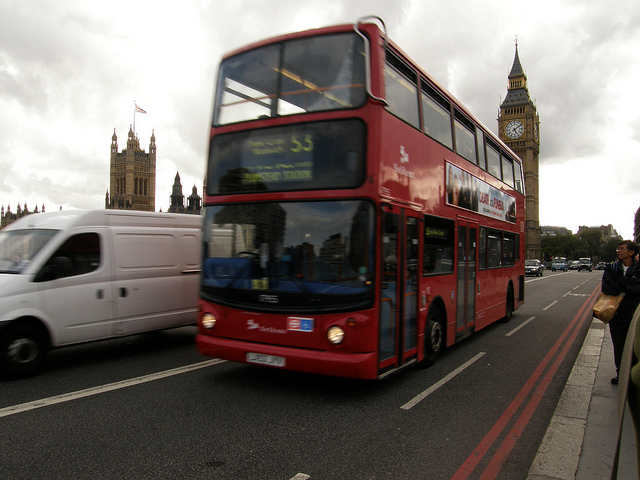<image>Which bus is the smallest? It is ambiguous which bus is the smallest. What two English words sound like the pronunciation of the black letters on the bus? There are no black letters on the bus. So, it is unknown what two English words sound like the pronunciation of non-existent black letters. What country do the flags represent? I am not sure the country of the flags. It can be seen Portugal, UK, France or others. Which bus is the smallest? I don't know which bus is the smallest. What two English words sound like the pronunciation of the black letters on the bus? I am not sure what two English words sound like the pronunciation of the black letters on the bus. What country do the flags represent? I am not sure what country the flags represent. It can be either United States, Portugal, UK, or England. 